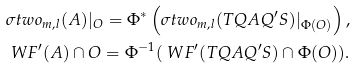<formula> <loc_0><loc_0><loc_500><loc_500>& \sigma t w o _ { m , l } ( A ) | _ { O } = \Phi ^ { * } \left ( \sigma t w o _ { m , l } ( T Q A Q ^ { \prime } S ) | _ { \Phi ( O ) } \right ) , \\ & \ W F ^ { \prime } ( A ) \cap O = \Phi ^ { - 1 } ( \ W F ^ { \prime } ( T Q A Q ^ { \prime } S ) \cap \Phi ( O ) ) .</formula> 